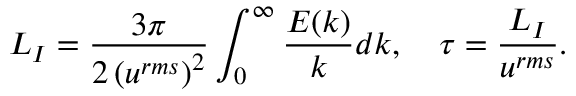Convert formula to latex. <formula><loc_0><loc_0><loc_500><loc_500>L _ { I } = \frac { 3 \pi } { 2 \left ( u ^ { r m s } \right ) ^ { 2 } } \int _ { 0 } ^ { \infty } \frac { E ( k ) } { k } d k , \quad \tau = \frac { L _ { I } } { u ^ { r m s } } .</formula> 